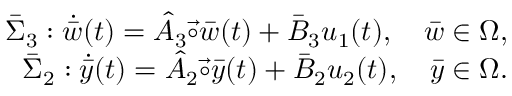Convert formula to latex. <formula><loc_0><loc_0><loc_500><loc_500>\begin{array} { r } { \bar { \Sigma } _ { 3 } \colon \dot { \bar { w } } ( t ) = \hat { A } _ { 3 } \vec { \circ } \bar { w } ( t ) + \bar { B } _ { 3 } u _ { 1 } ( t ) , \quad \bar { w } \in \Omega , } \\ { \bar { \Sigma } _ { 2 } \colon \dot { \bar { y } } ( t ) = \hat { A } _ { 2 } \vec { \circ } \bar { y } ( t ) + \bar { B } _ { 2 } u _ { 2 } ( t ) , \quad \bar { y } \in \Omega . } \end{array}</formula> 